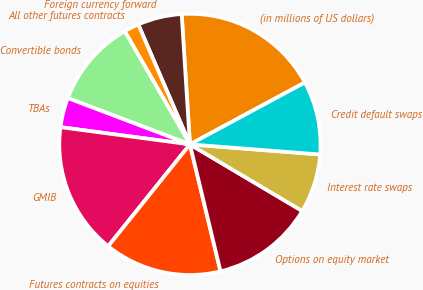<chart> <loc_0><loc_0><loc_500><loc_500><pie_chart><fcel>(in millions of US dollars)<fcel>Foreign currency forward<fcel>All other futures contracts<fcel>Convertible bonds<fcel>TBAs<fcel>GMIB<fcel>Futures contracts on equities<fcel>Options on equity market<fcel>Interest rate swaps<fcel>Credit default swaps<nl><fcel>18.15%<fcel>5.47%<fcel>1.85%<fcel>10.91%<fcel>3.66%<fcel>16.34%<fcel>14.53%<fcel>12.72%<fcel>7.28%<fcel>9.09%<nl></chart> 